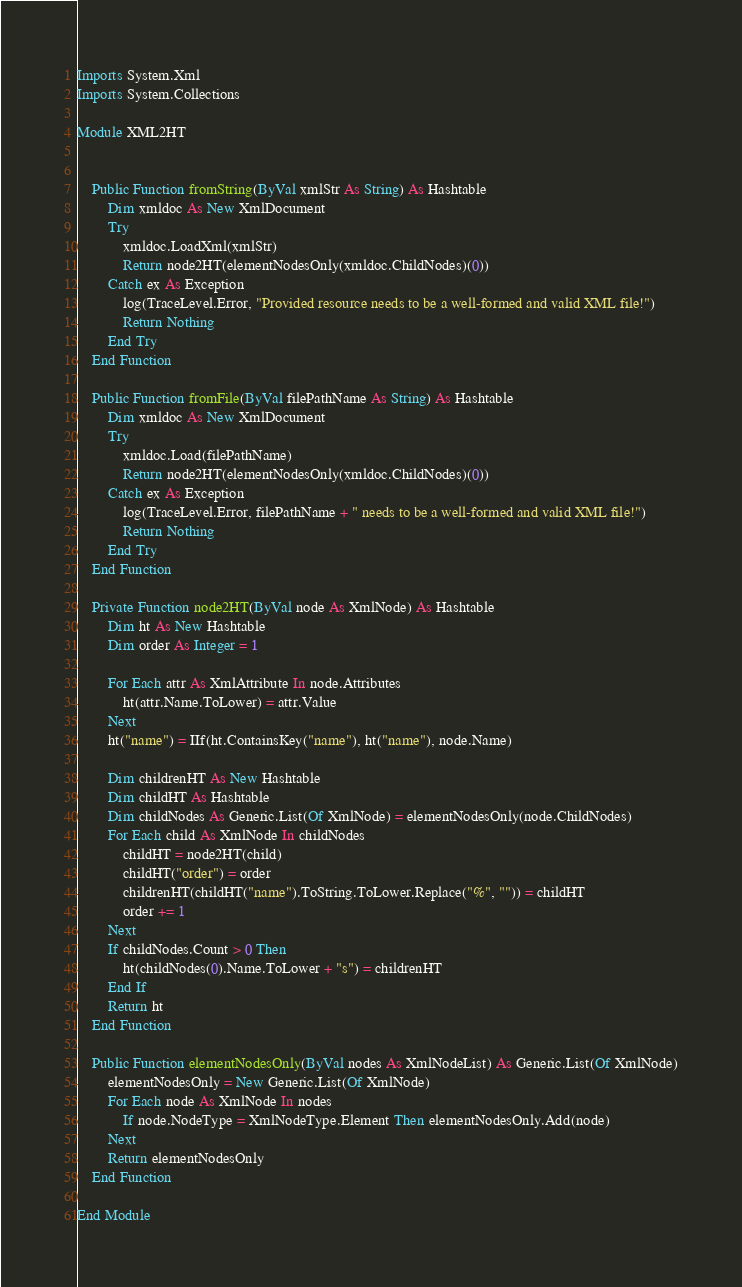<code> <loc_0><loc_0><loc_500><loc_500><_VisualBasic_>Imports System.Xml
Imports System.Collections

Module XML2HT


    Public Function fromString(ByVal xmlStr As String) As Hashtable
        Dim xmldoc As New XmlDocument
        Try
            xmldoc.LoadXml(xmlStr)
            Return node2HT(elementNodesOnly(xmldoc.ChildNodes)(0))
        Catch ex As Exception
            log(TraceLevel.Error, "Provided resource needs to be a well-formed and valid XML file!")
            Return Nothing
        End Try
    End Function

    Public Function fromFile(ByVal filePathName As String) As Hashtable
        Dim xmldoc As New XmlDocument
        Try
            xmldoc.Load(filePathName)
            Return node2HT(elementNodesOnly(xmldoc.ChildNodes)(0))
        Catch ex As Exception
            log(TraceLevel.Error, filePathName + " needs to be a well-formed and valid XML file!")
            Return Nothing
        End Try
    End Function

    Private Function node2HT(ByVal node As XmlNode) As Hashtable
        Dim ht As New Hashtable
        Dim order As Integer = 1

        For Each attr As XmlAttribute In node.Attributes
            ht(attr.Name.ToLower) = attr.Value
        Next
        ht("name") = IIf(ht.ContainsKey("name"), ht("name"), node.Name)

        Dim childrenHT As New Hashtable
        Dim childHT As Hashtable
        Dim childNodes As Generic.List(Of XmlNode) = elementNodesOnly(node.ChildNodes)
        For Each child As XmlNode In childNodes
            childHT = node2HT(child)
            childHT("order") = order
            childrenHT(childHT("name").ToString.ToLower.Replace("%", "")) = childHT
            order += 1
        Next
        If childNodes.Count > 0 Then
            ht(childNodes(0).Name.ToLower + "s") = childrenHT
        End If
        Return ht
    End Function

    Public Function elementNodesOnly(ByVal nodes As XmlNodeList) As Generic.List(Of XmlNode)
        elementNodesOnly = New Generic.List(Of XmlNode)
        For Each node As XmlNode In nodes
            If node.NodeType = XmlNodeType.Element Then elementNodesOnly.Add(node)
        Next
        Return elementNodesOnly
    End Function

End Module
</code> 